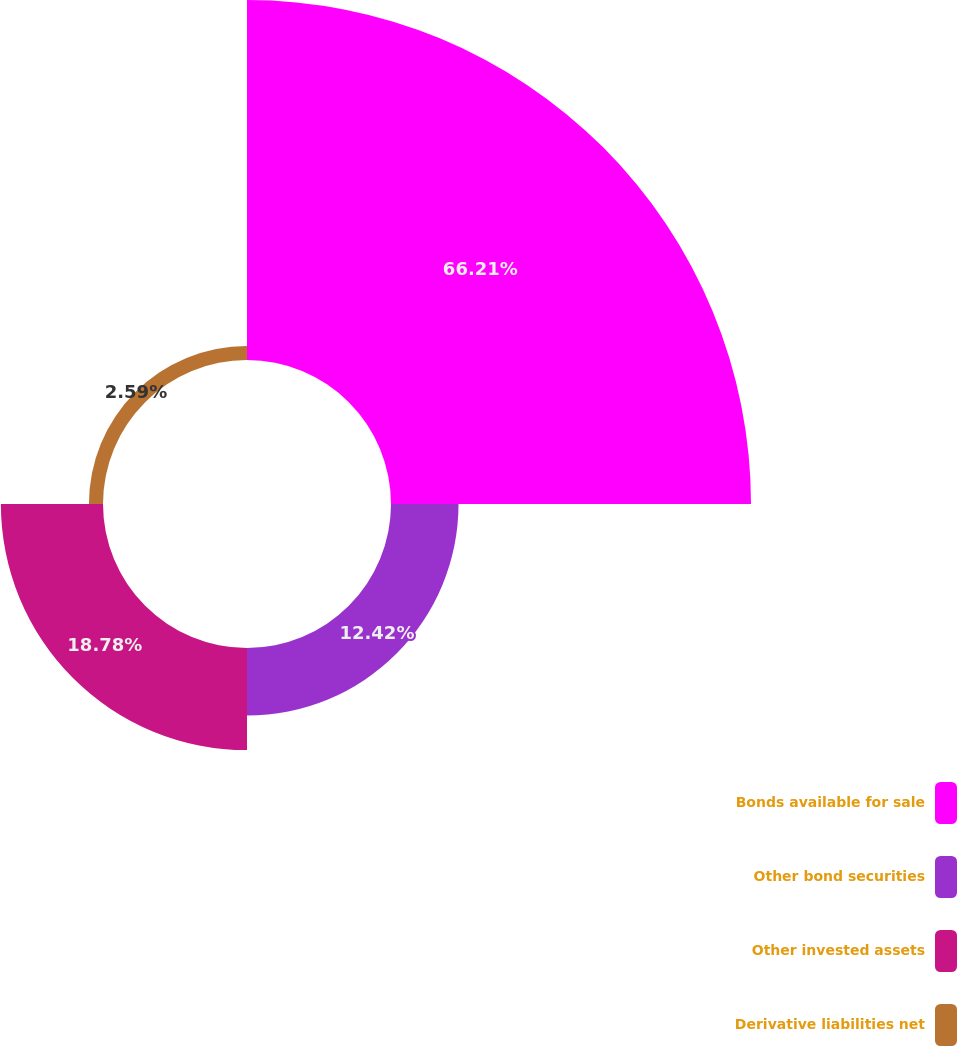<chart> <loc_0><loc_0><loc_500><loc_500><pie_chart><fcel>Bonds available for sale<fcel>Other bond securities<fcel>Other invested assets<fcel>Derivative liabilities net<nl><fcel>66.21%<fcel>12.42%<fcel>18.78%<fcel>2.59%<nl></chart> 